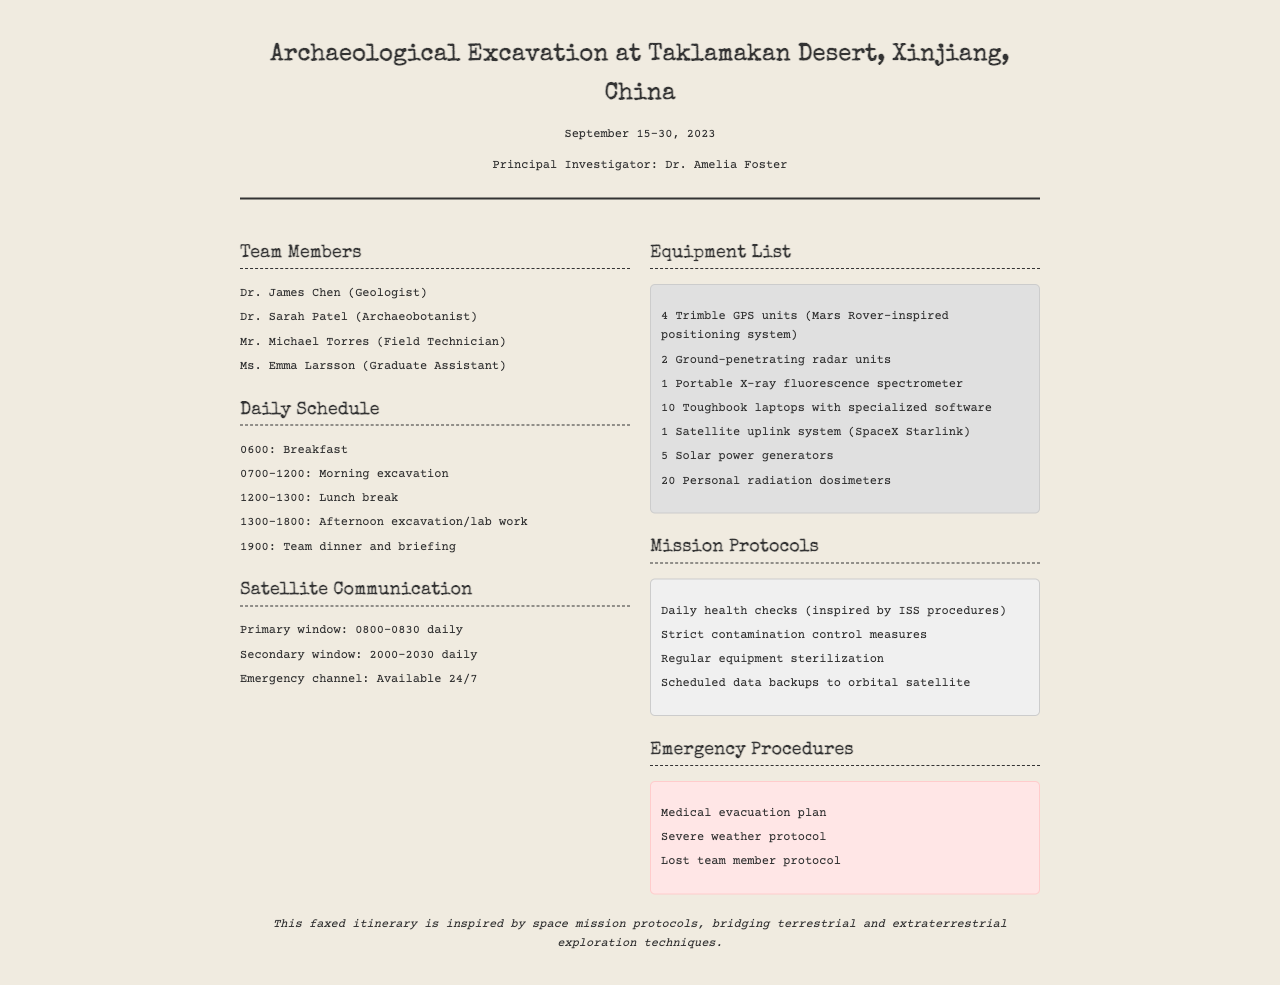What is the duration of the expedition? The expedition is scheduled from September 15 to September 30, 2023, indicating a duration of 15 days.
Answer: 15 days Who is the Principal Investigator? The document specifies that Dr. Amelia Foster is the Principal Investigator of the expedition.
Answer: Dr. Amelia Foster What time is the emergency communication channel available? The document states that the emergency channel is available 24/7, which indicates continuous availability.
Answer: 24/7 How many Ground-penetrating radar units are listed? The listed equipment specifies that there are 2 Ground-penetrating radar units available for the expedition.
Answer: 2 What is one of the strict measures outlined in the mission protocols? The mission protocols mention strict contamination control measures as one of the necessary procedures.
Answer: Strict contamination control measures What is the primary communication window time? The faxed itinerary outlines that the primary window for satellite communication is from 0800 to 0830 daily.
Answer: 0800-0830 How many personal radiation dosimeters are included in the equipment list? The equipment list specifies that there are a total of 20 personal radiation dosimeters included for the expedition team.
Answer: 20 What does the last statement of the document emphasize? The last statement indicates that the faxed itinerary is inspired by space mission protocols, highlighting the blending of exploration techniques.
Answer: Space mission protocols 